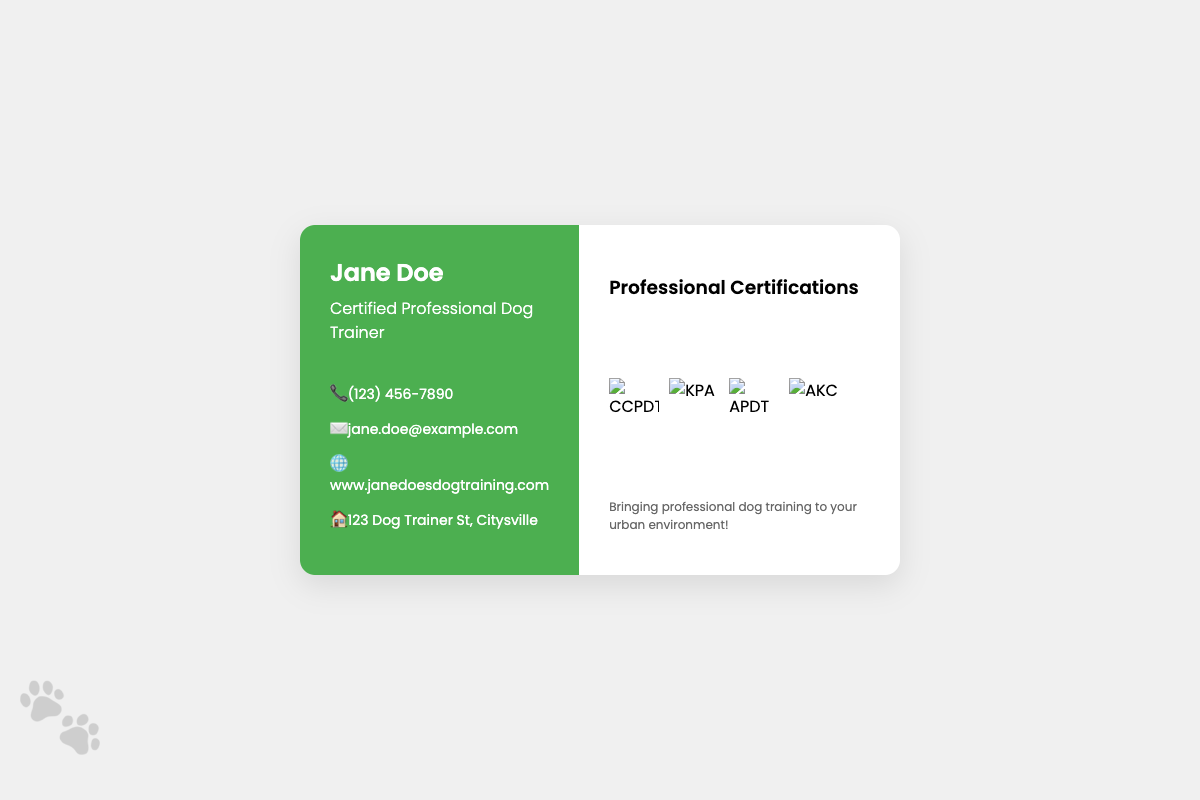What is the name of the dog trainer? The name is prominently displayed at the top of the business card.
Answer: Jane Doe What are the professional certifications listed? The certifications are presented in a clear format with logos next to them.
Answer: CPDT-KA, KPA-CTP, APDT Member, AKC CGC Evaluator What is the phone number provided? The contact information includes a phone number that is easy to spot.
Answer: (123) 456-7890 What city does the dog trainer reside in? The address section specifies the residential city.
Answer: Citysville What is the purpose of the document? This business card serves to promote a specific profession, as indicated by the title.
Answer: Dog Trainer How many certification logos are displayed? A count of the logos will reveal the number of certifications presented.
Answer: 4 What visual element enhances the design of the card? A decorative touch is added to the design through graphical representation.
Answer: Paw print What does "KPA" stand for in the certifications? Knowing the organization behind the certification helps in understanding professional affiliations.
Answer: Karen Pryor Academy What is the website for the dog trainer? The website is clearly detailed in the contact section, directing clients to further resources.
Answer: www.janedoesdogtraining.com 